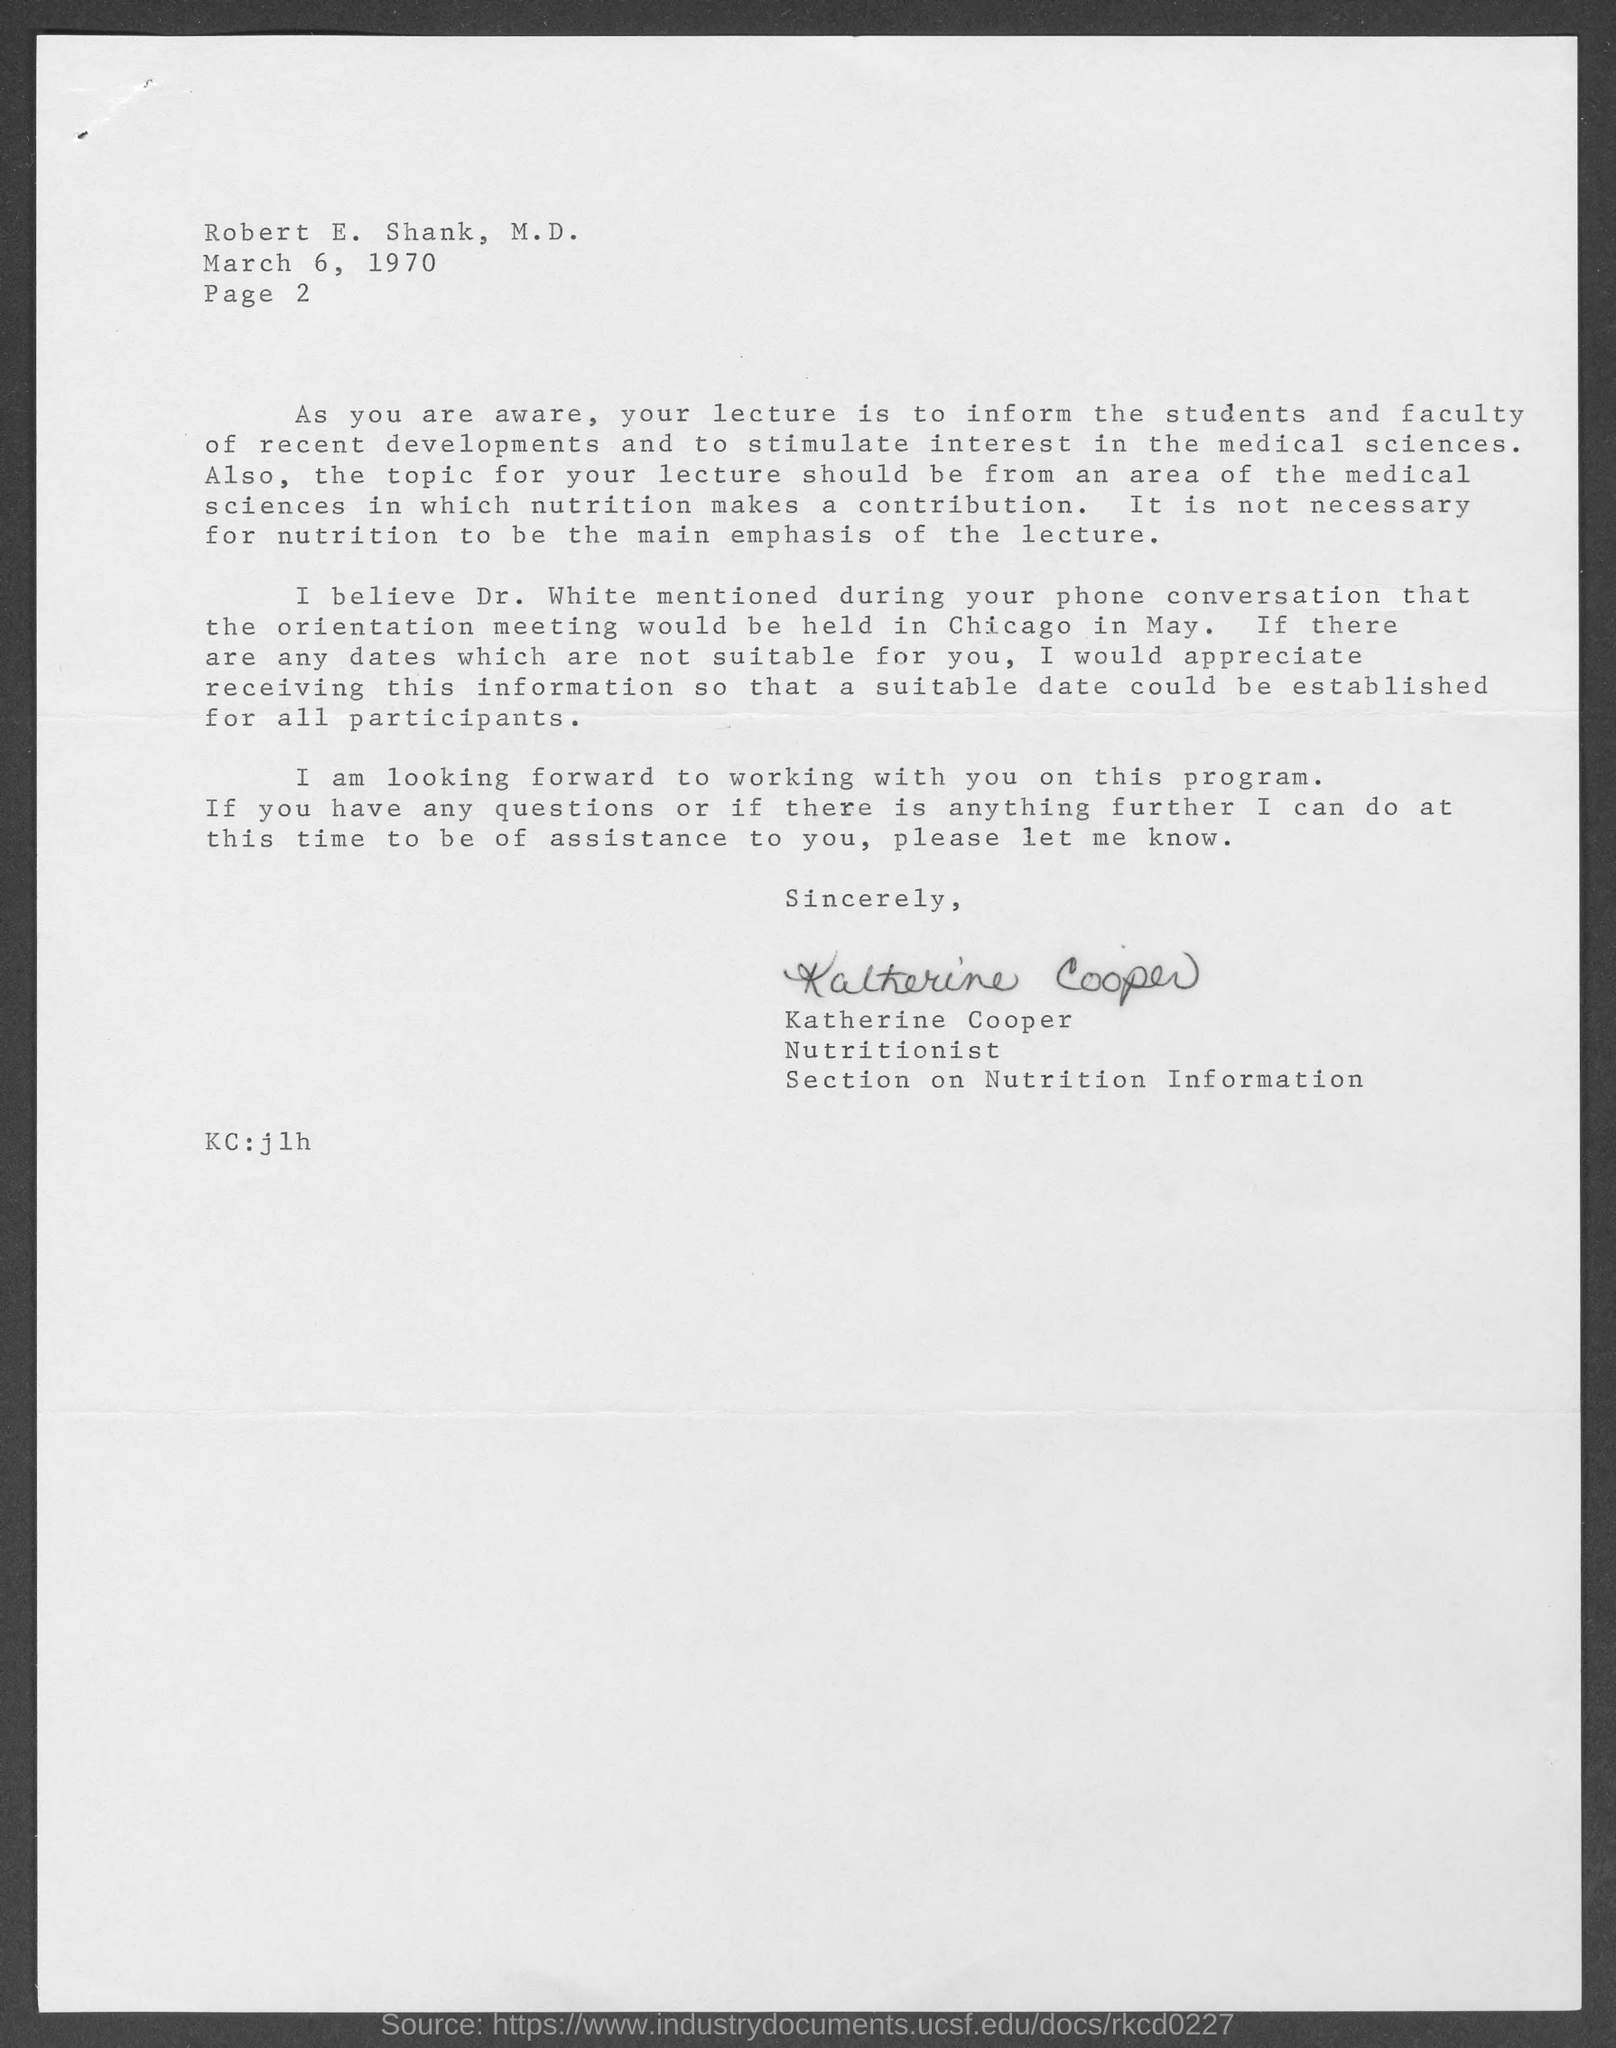Identify some key points in this picture. The memorandum is dated on March 6, 1970. The document contains a page number written as 2.. The letter was written by Katherine Cooper. 